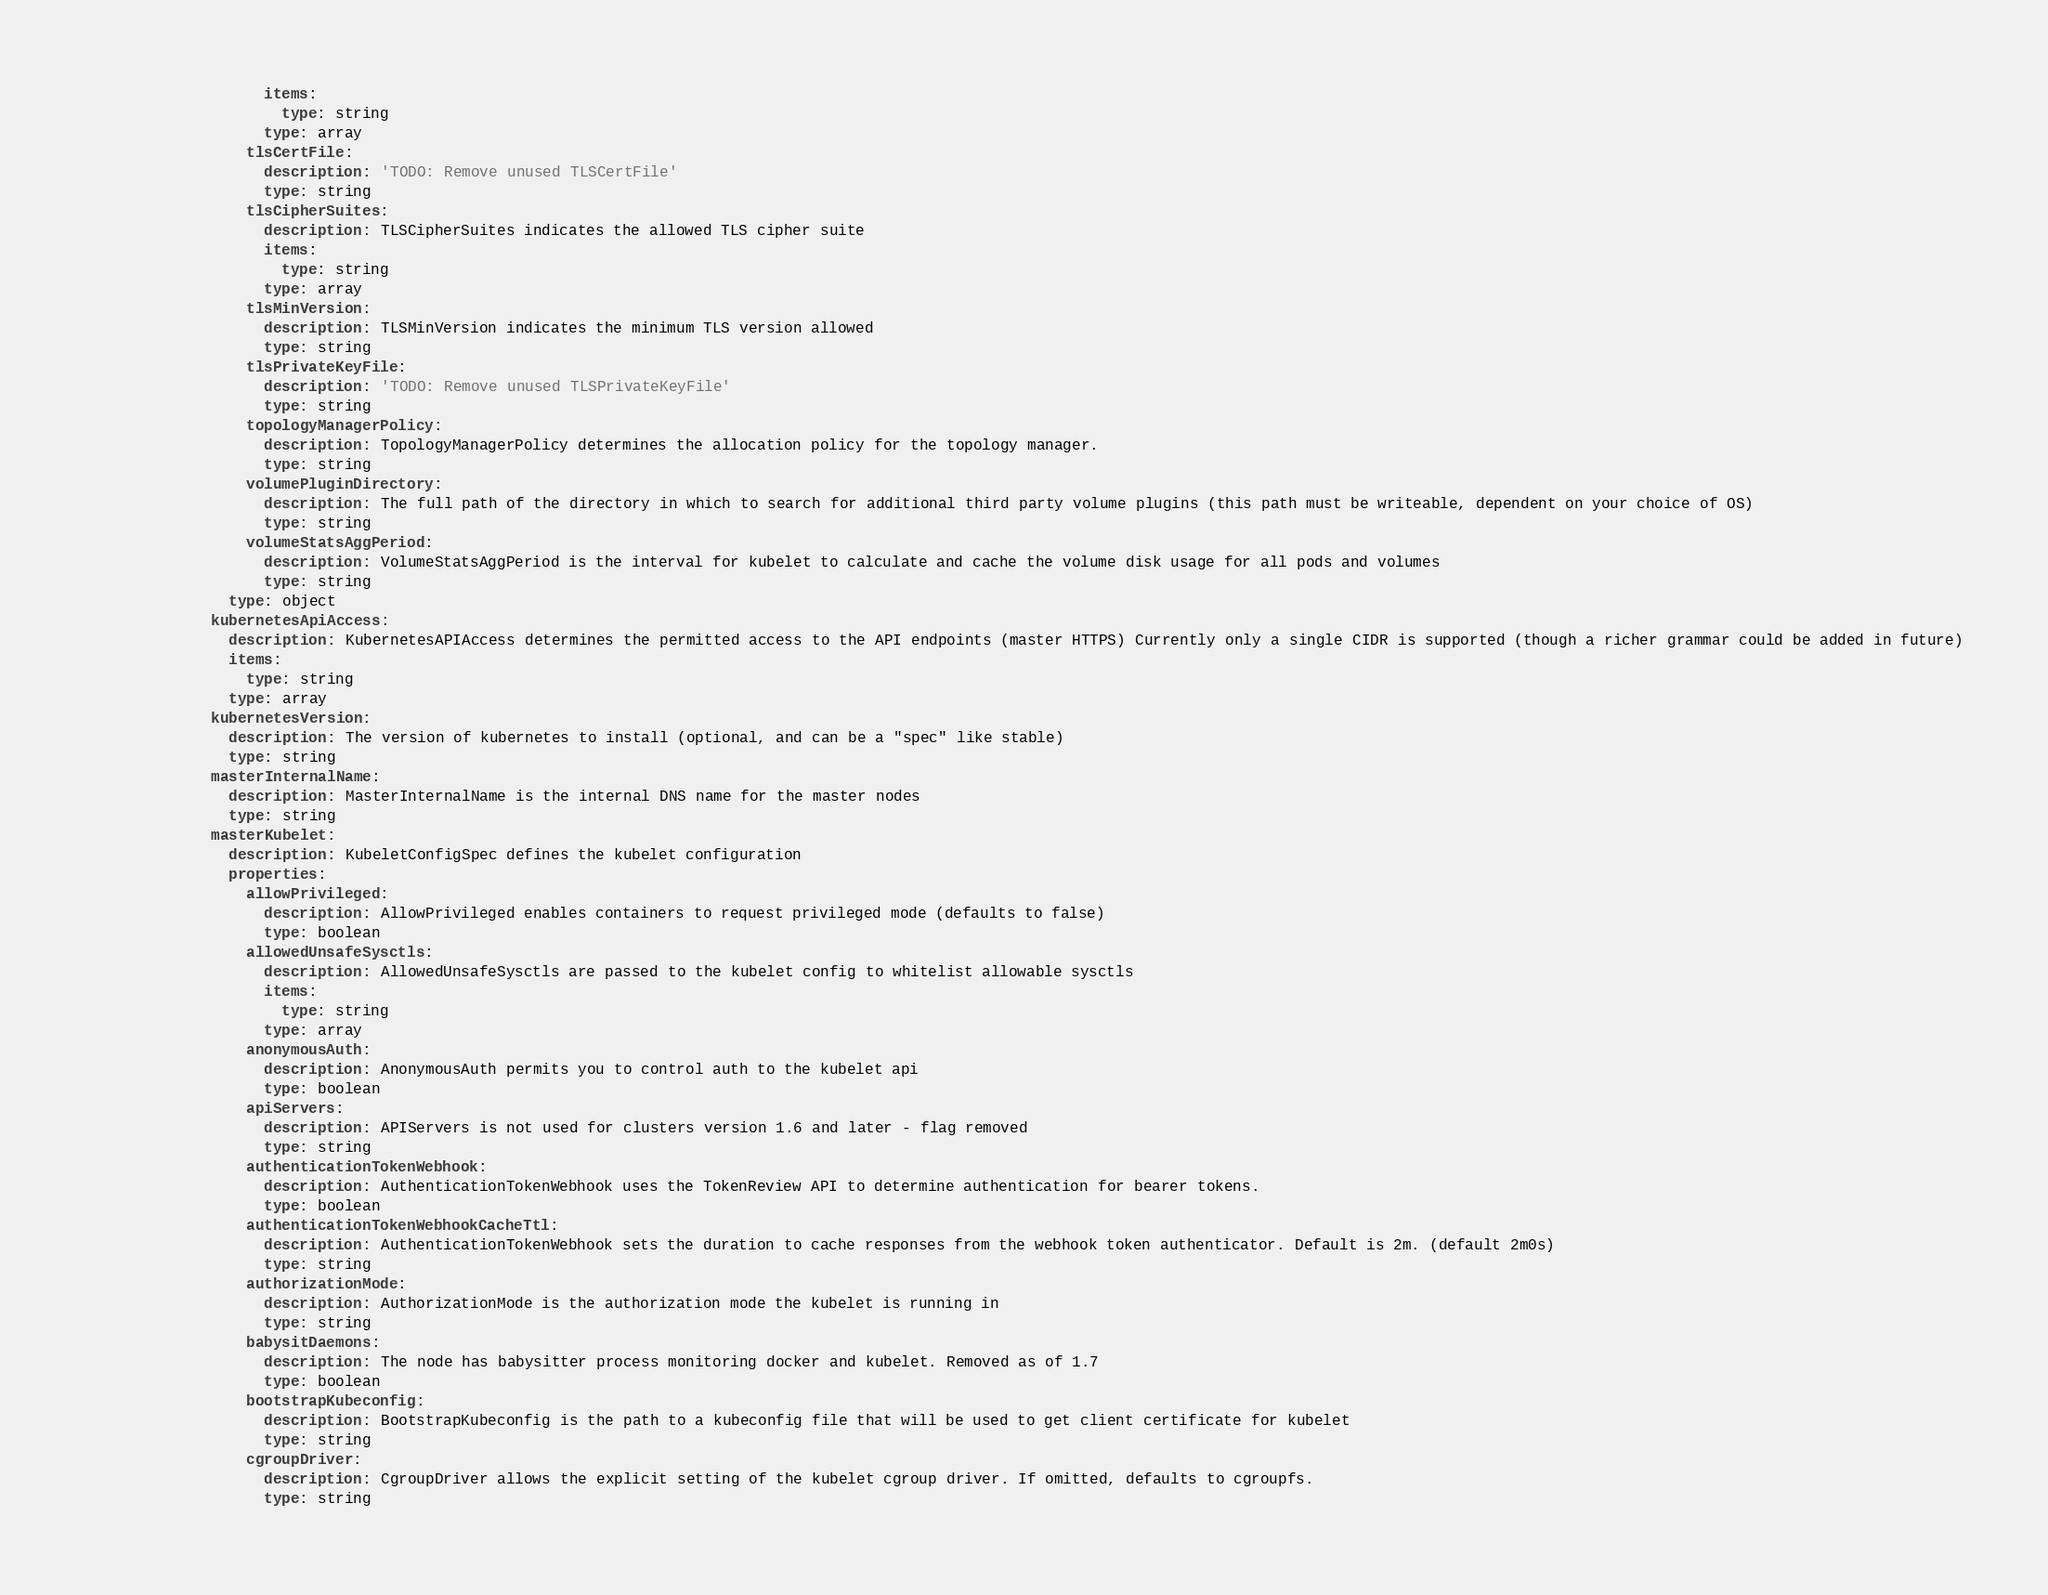<code> <loc_0><loc_0><loc_500><loc_500><_YAML_>                    items:
                      type: string
                    type: array
                  tlsCertFile:
                    description: 'TODO: Remove unused TLSCertFile'
                    type: string
                  tlsCipherSuites:
                    description: TLSCipherSuites indicates the allowed TLS cipher suite
                    items:
                      type: string
                    type: array
                  tlsMinVersion:
                    description: TLSMinVersion indicates the minimum TLS version allowed
                    type: string
                  tlsPrivateKeyFile:
                    description: 'TODO: Remove unused TLSPrivateKeyFile'
                    type: string
                  topologyManagerPolicy:
                    description: TopologyManagerPolicy determines the allocation policy for the topology manager.
                    type: string
                  volumePluginDirectory:
                    description: The full path of the directory in which to search for additional third party volume plugins (this path must be writeable, dependent on your choice of OS)
                    type: string
                  volumeStatsAggPeriod:
                    description: VolumeStatsAggPeriod is the interval for kubelet to calculate and cache the volume disk usage for all pods and volumes
                    type: string
                type: object
              kubernetesApiAccess:
                description: KubernetesAPIAccess determines the permitted access to the API endpoints (master HTTPS) Currently only a single CIDR is supported (though a richer grammar could be added in future)
                items:
                  type: string
                type: array
              kubernetesVersion:
                description: The version of kubernetes to install (optional, and can be a "spec" like stable)
                type: string
              masterInternalName:
                description: MasterInternalName is the internal DNS name for the master nodes
                type: string
              masterKubelet:
                description: KubeletConfigSpec defines the kubelet configuration
                properties:
                  allowPrivileged:
                    description: AllowPrivileged enables containers to request privileged mode (defaults to false)
                    type: boolean
                  allowedUnsafeSysctls:
                    description: AllowedUnsafeSysctls are passed to the kubelet config to whitelist allowable sysctls
                    items:
                      type: string
                    type: array
                  anonymousAuth:
                    description: AnonymousAuth permits you to control auth to the kubelet api
                    type: boolean
                  apiServers:
                    description: APIServers is not used for clusters version 1.6 and later - flag removed
                    type: string
                  authenticationTokenWebhook:
                    description: AuthenticationTokenWebhook uses the TokenReview API to determine authentication for bearer tokens.
                    type: boolean
                  authenticationTokenWebhookCacheTtl:
                    description: AuthenticationTokenWebhook sets the duration to cache responses from the webhook token authenticator. Default is 2m. (default 2m0s)
                    type: string
                  authorizationMode:
                    description: AuthorizationMode is the authorization mode the kubelet is running in
                    type: string
                  babysitDaemons:
                    description: The node has babysitter process monitoring docker and kubelet. Removed as of 1.7
                    type: boolean
                  bootstrapKubeconfig:
                    description: BootstrapKubeconfig is the path to a kubeconfig file that will be used to get client certificate for kubelet
                    type: string
                  cgroupDriver:
                    description: CgroupDriver allows the explicit setting of the kubelet cgroup driver. If omitted, defaults to cgroupfs.
                    type: string</code> 